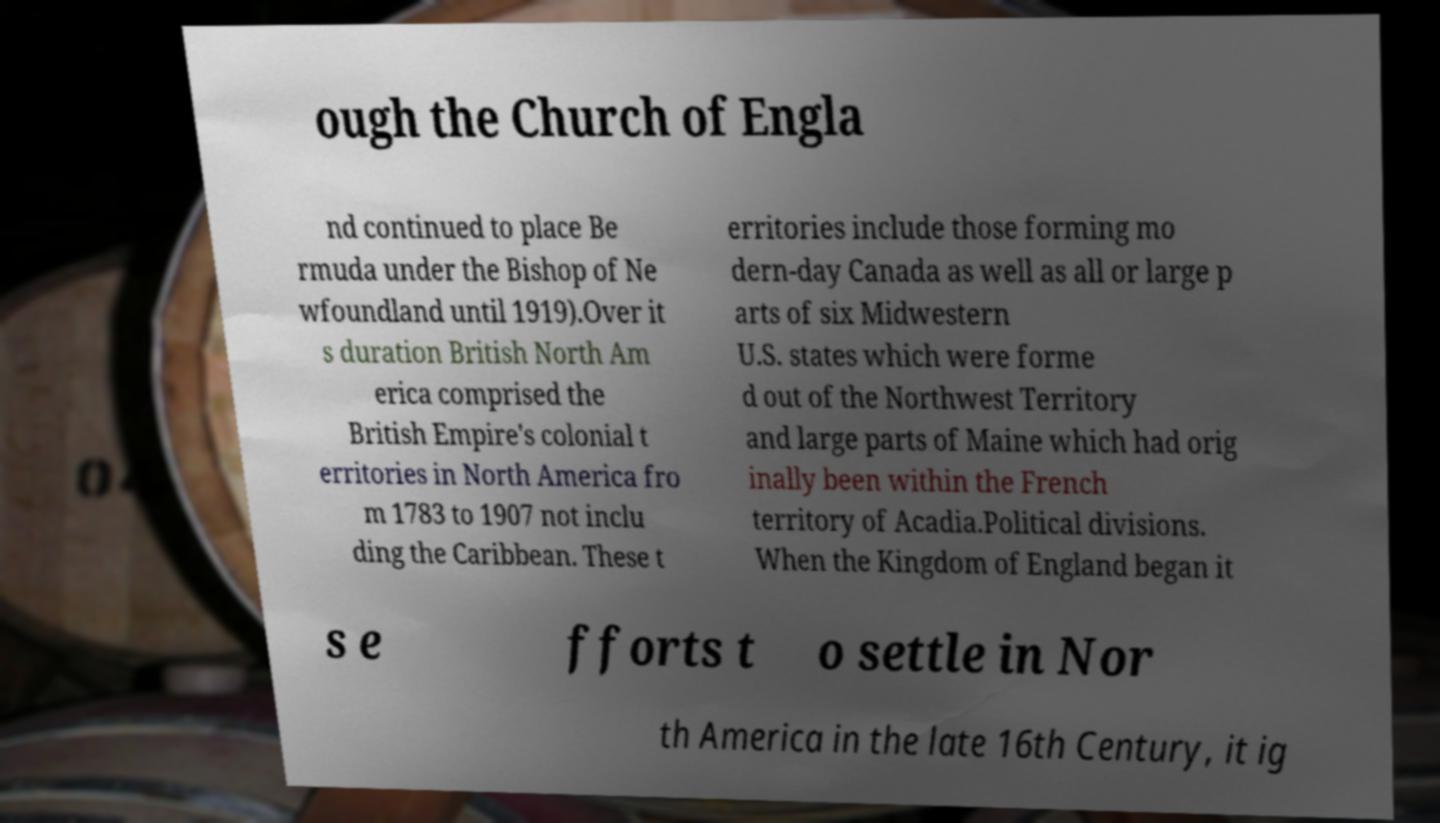Could you assist in decoding the text presented in this image and type it out clearly? ough the Church of Engla nd continued to place Be rmuda under the Bishop of Ne wfoundland until 1919).Over it s duration British North Am erica comprised the British Empire's colonial t erritories in North America fro m 1783 to 1907 not inclu ding the Caribbean. These t erritories include those forming mo dern-day Canada as well as all or large p arts of six Midwestern U.S. states which were forme d out of the Northwest Territory and large parts of Maine which had orig inally been within the French territory of Acadia.Political divisions. When the Kingdom of England began it s e fforts t o settle in Nor th America in the late 16th Century, it ig 